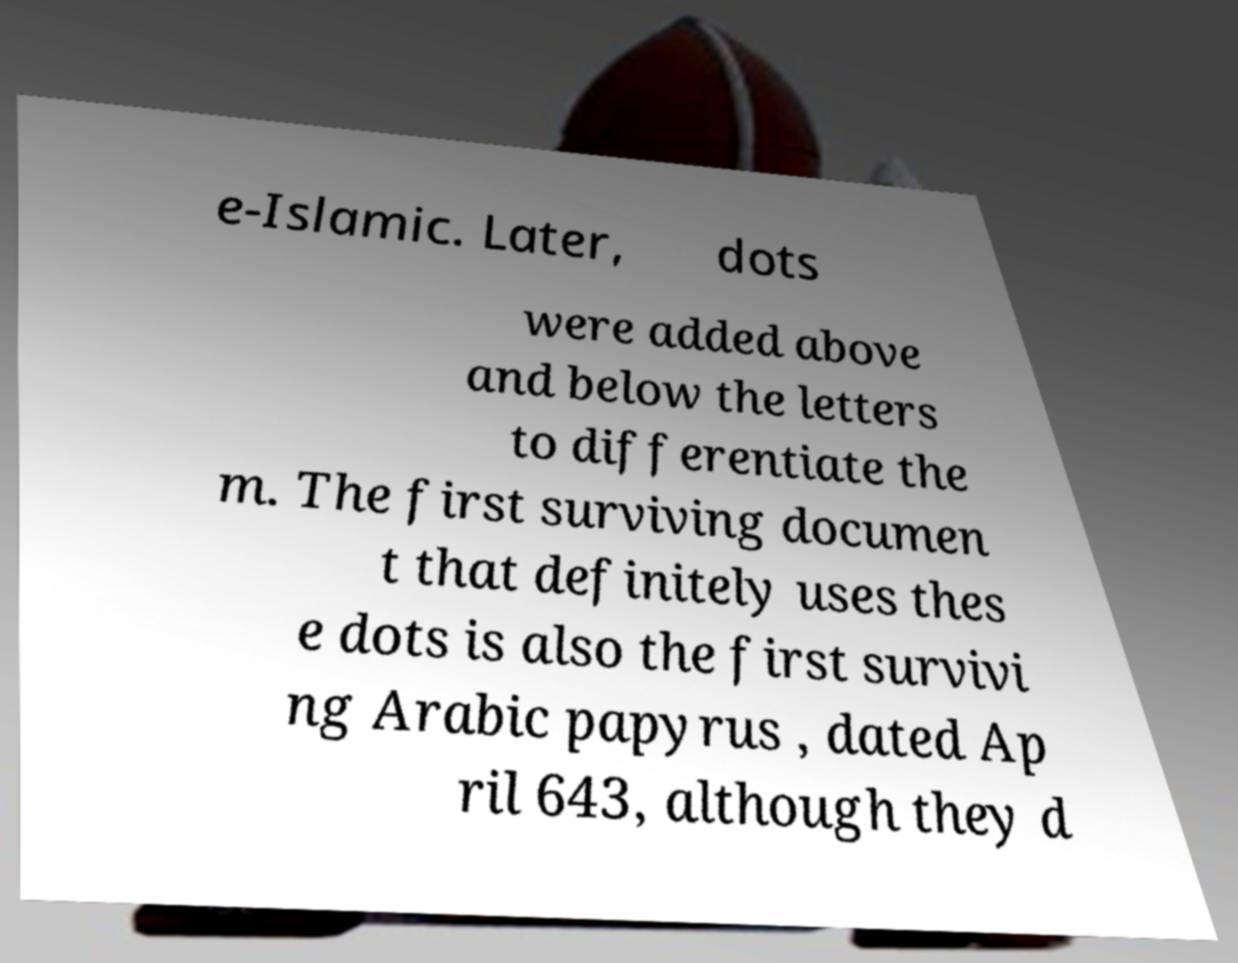Please read and relay the text visible in this image. What does it say? e-Islamic. Later, dots were added above and below the letters to differentiate the m. The first surviving documen t that definitely uses thes e dots is also the first survivi ng Arabic papyrus , dated Ap ril 643, although they d 